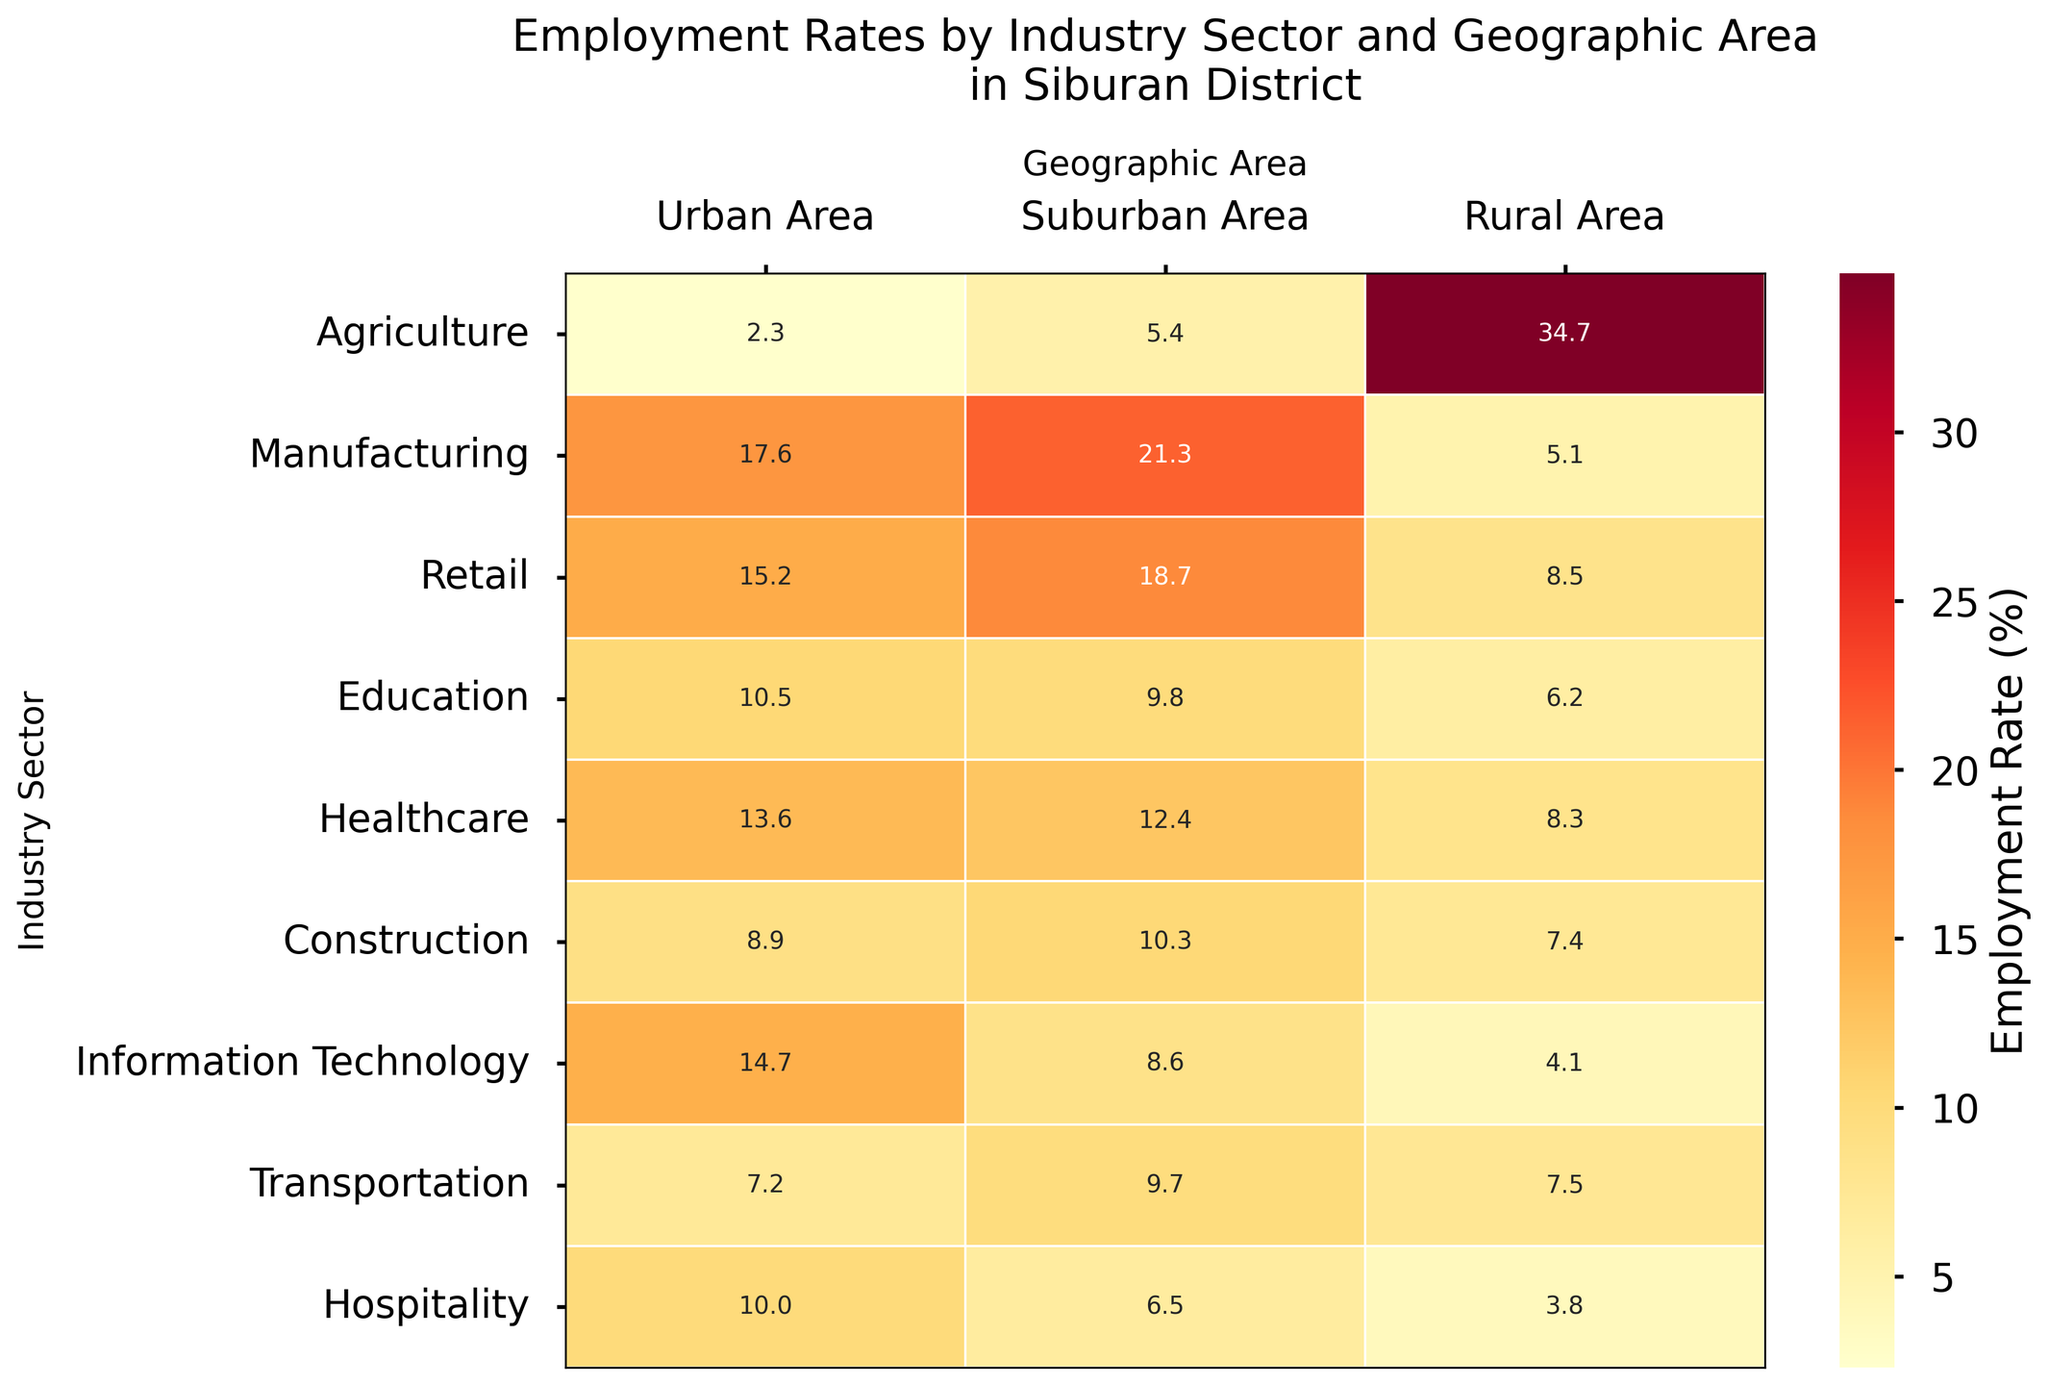What's the title of the figure? The title of the figure is provided at the top of the heatmap.
Answer: Employment Rates by Industry Sector and Geographic Area in Siburan District What industry sector has the highest employment rate in Rural Areas? To find this, look at the column for 'Rural Area' and identify the cell with the highest value.
Answer: Agriculture Which geographic area has the highest employment rate in the Manufacturing sector? By examining the 'Manufacturing' row, compare the employment rates across 'Urban Area,' 'Suburban Area,' and 'Rural Area.'
Answer: Suburban Area What is the employment rate for Healthcare in the Suburban Area? Locate the Healthcare row and the Suburban Area column to find the corresponding value.
Answer: 12.4% Calculate the average employment rate in Retail across all geographic areas. Sum the values for Retail in Urban Area, Suburban Area, and Rural Area, and divide by the number of geographic areas ((15.2 + 18.7 + 8.5) / 3).
Answer: 14.1% Which industry has the smallest range of employment rates across all geographic areas? To find the range, calculate the difference between the highest and lowest employment rates for each industry and identify the industry with the smallest difference.
Answer: Education Is the employment rate in Agriculture higher in Suburban or Urban Areas, and by how much? Compare the values for Agriculture in Suburban Area and Urban Area and find the difference (5.4 - 2.3).
Answer: Suburban is higher by 3.1% In which industry is the employment rate nearly equal between Urban and Suburban Areas? By comparing the values, identify an industry where the employment rates in Urban and Suburban Areas are close to each other.
Answer: Education Which geographic area has the highest overall employment rates across all industries? Calculate the sum of employment rates for each geographic area and compare them to find the highest.
Answer: Suburban Area Determine the employment rate difference between Information Technology in Rural and Urban Areas. Subtract the employment rate of Information Technology in Rural Area from the Urban Area (14.7 - 4.1).
Answer: 10.6% 